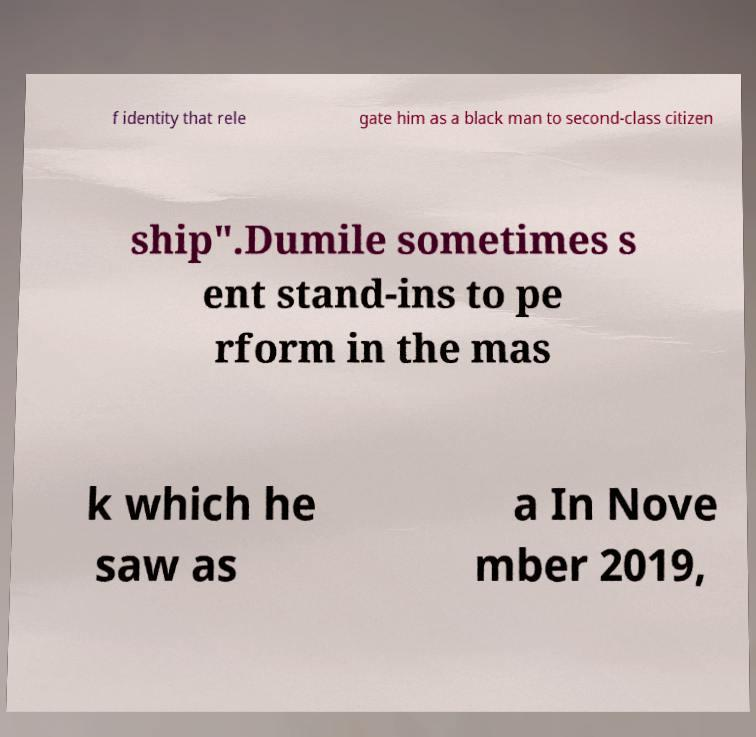I need the written content from this picture converted into text. Can you do that? f identity that rele gate him as a black man to second-class citizen ship".Dumile sometimes s ent stand-ins to pe rform in the mas k which he saw as a In Nove mber 2019, 